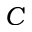Convert formula to latex. <formula><loc_0><loc_0><loc_500><loc_500>C</formula> 